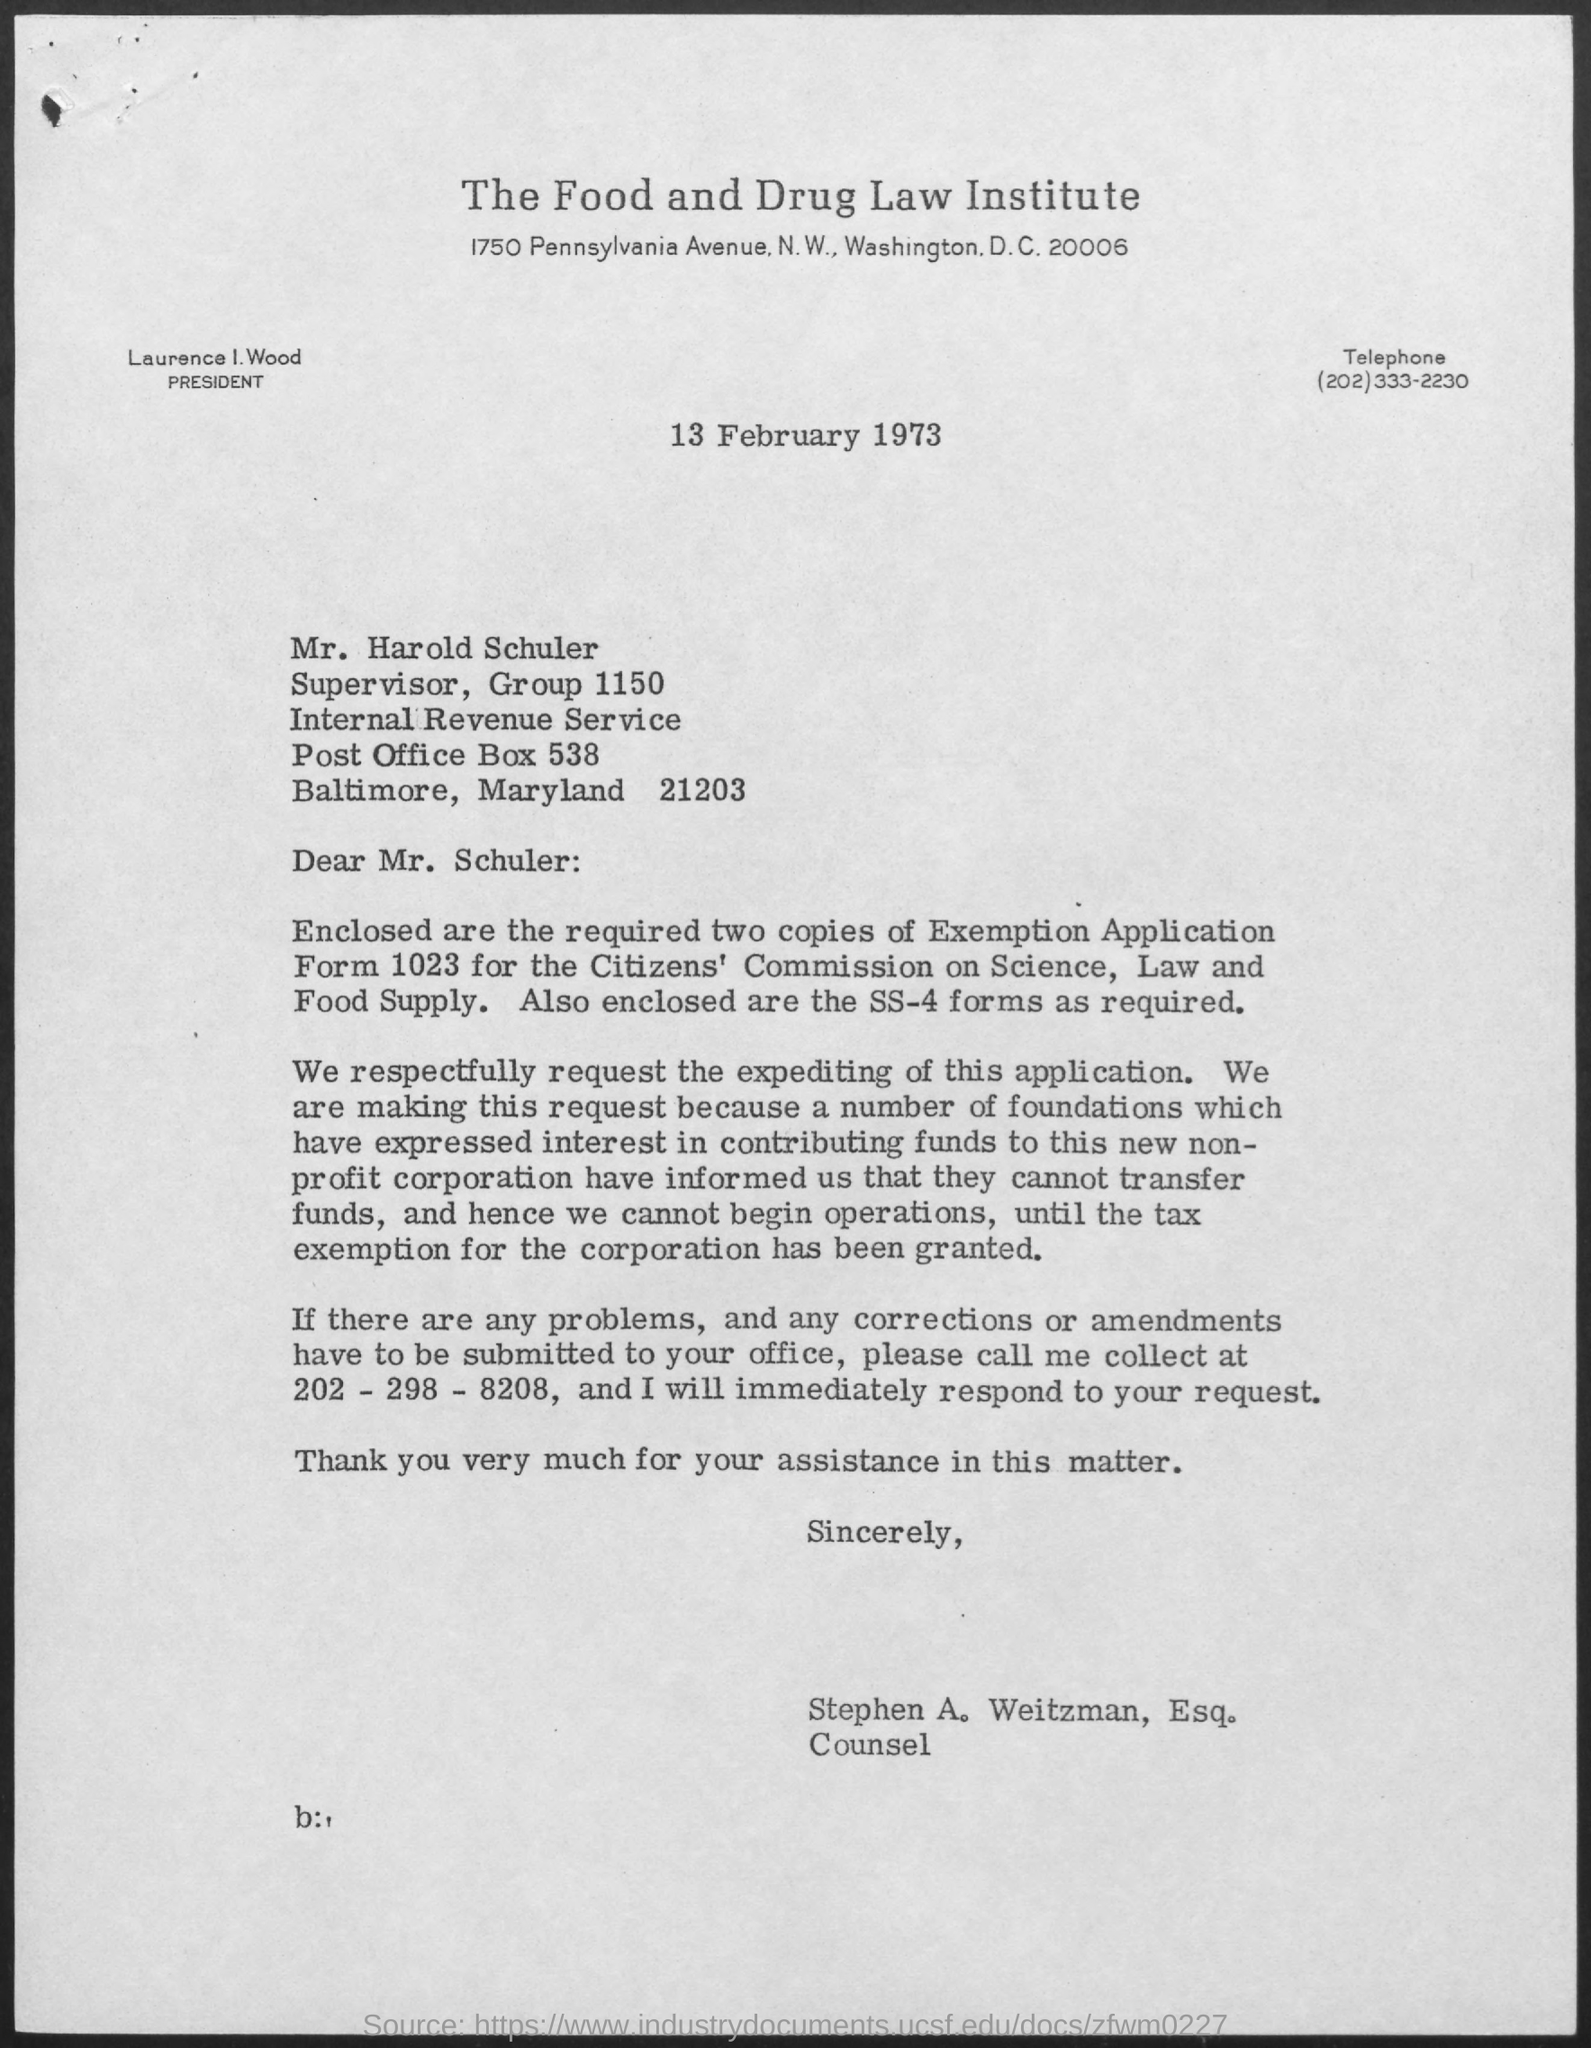Give some essential details in this illustration. The president of the Institute is Laurence I. Wood. The document was written by Stephen A. Weitzman, an attorney at law. The heading of the document is: "The Food and Drug Law Institute. The date mentioned is 13 February 1973. 